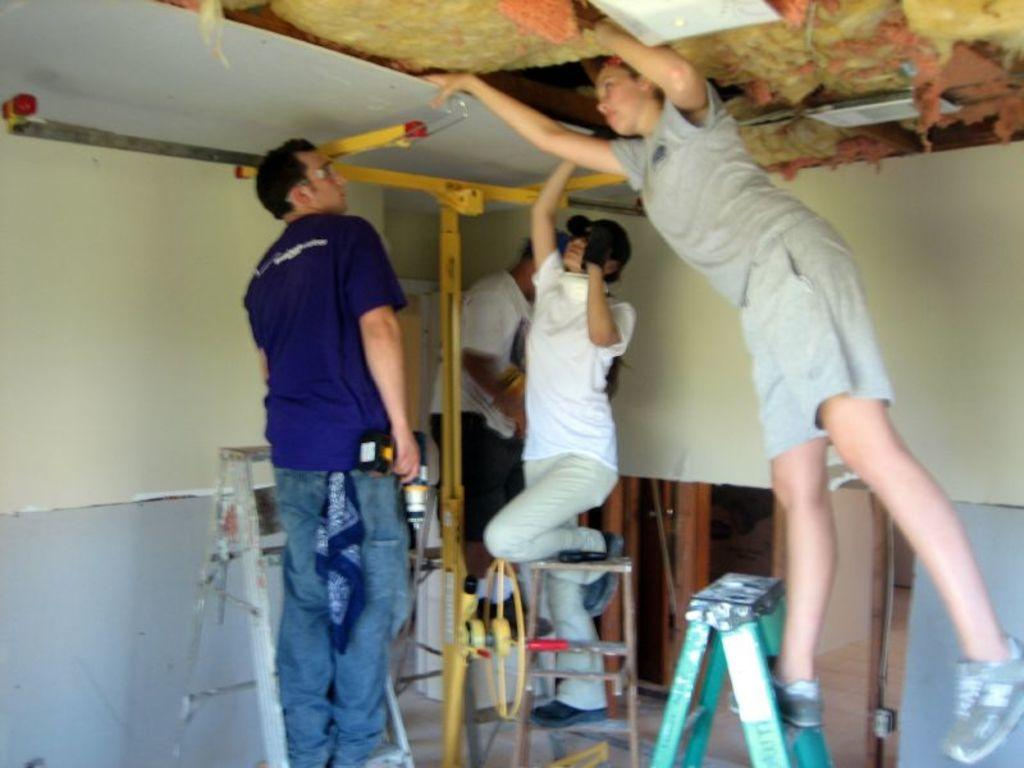What type of location is depicted in the image? The image is an inside view of a room. How many people are present in the image? There are four people in the image. Can you describe the gender of the people in the image? Two of the people are women, and two are men. What are the people doing in the image? The people are standing on ladders. What can be seen in the background of the image? There are walls visible in the background of the image. Are there any cherries visible on the ladders in the image? There are no cherries present in the image, and they are not visible on the ladders. What type of camp can be seen in the background of the image? There is no camp visible in the image, as it is an inside view of a room with walls in the background. 